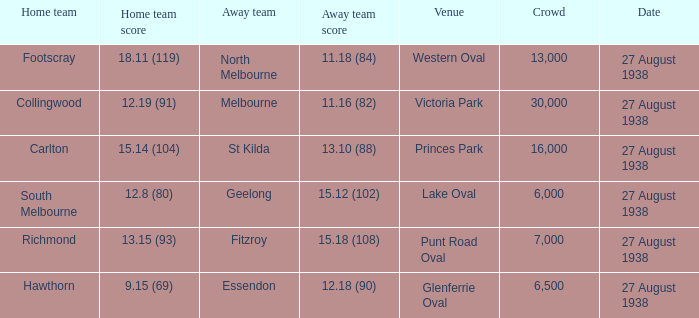Which squad performs at western oval? Footscray. 